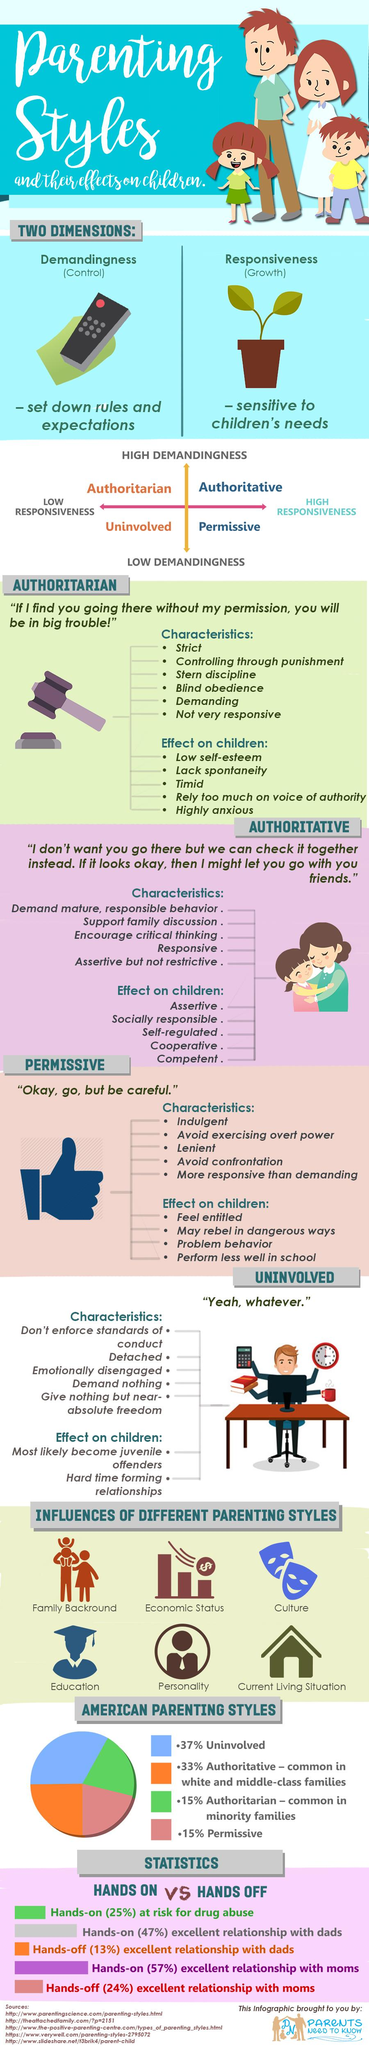Indicate a few pertinent items in this graphic. Permissive parenting is characterized by low demandingness and high responsiveness, leading to a lack of structure and clear expectations for behavior, which can result in negative outcomes for the child. Authoritative parenting is the second most common parenting style in America. Authoritative parenting is characterized by high demandingness and high responsiveness, with a cause and effect relationship between the two. High demandingness leads to high responsiveness, which in turn leads to positive outcomes for the child, such as better behavior and academic performance. Parenting style is influenced by several factors, including the child's temperament, the parent's personal experiences and values, the parent's beliefs about child-rearing, the parent's knowledge and skills, and the parent's personality. Personality is considered to be the fifth factor that affects parenting style. Authoritarian parenting, characterized by high demandingness and low responsiveness, has been shown to cause and effect negative outcomes for children's emotional, behavioral, and cognitive development. 